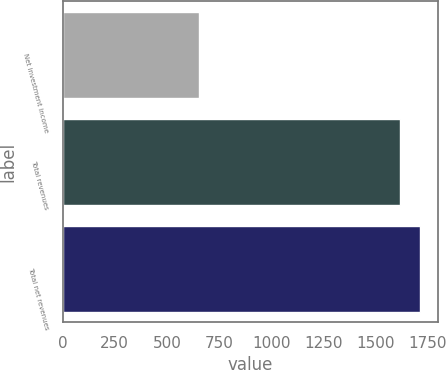Convert chart. <chart><loc_0><loc_0><loc_500><loc_500><bar_chart><fcel>Net investment income<fcel>Total revenues<fcel>Total net revenues<nl><fcel>652<fcel>1618<fcel>1714.6<nl></chart> 